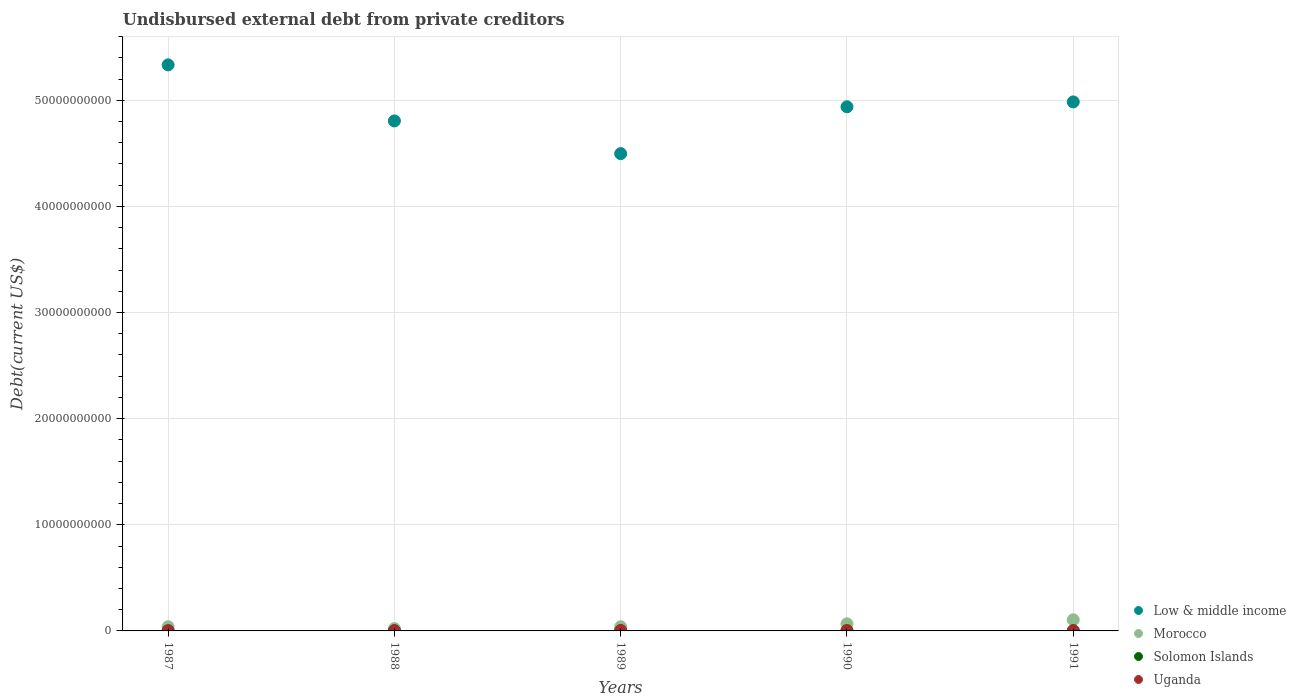Is the number of dotlines equal to the number of legend labels?
Provide a short and direct response. Yes. What is the total debt in Solomon Islands in 1988?
Keep it short and to the point. 1.50e+07. Across all years, what is the maximum total debt in Uganda?
Give a very brief answer. 3.76e+07. Across all years, what is the minimum total debt in Morocco?
Ensure brevity in your answer.  2.19e+08. What is the total total debt in Uganda in the graph?
Keep it short and to the point. 1.10e+08. What is the difference between the total debt in Uganda in 1987 and that in 1988?
Make the answer very short. 3.02e+06. What is the difference between the total debt in Solomon Islands in 1991 and the total debt in Uganda in 1988?
Your answer should be compact. 2.96e+06. What is the average total debt in Solomon Islands per year?
Offer a terse response. 1.50e+07. In the year 1987, what is the difference between the total debt in Solomon Islands and total debt in Low & middle income?
Keep it short and to the point. -5.33e+1. What is the ratio of the total debt in Low & middle income in 1987 to that in 1991?
Your answer should be very brief. 1.07. What is the difference between the highest and the second highest total debt in Uganda?
Your answer should be very brief. 1.44e+07. What is the difference between the highest and the lowest total debt in Low & middle income?
Offer a terse response. 8.36e+09. In how many years, is the total debt in Low & middle income greater than the average total debt in Low & middle income taken over all years?
Provide a succinct answer. 3. Is the sum of the total debt in Uganda in 1987 and 1989 greater than the maximum total debt in Morocco across all years?
Give a very brief answer. No. Is it the case that in every year, the sum of the total debt in Solomon Islands and total debt in Uganda  is greater than the total debt in Morocco?
Your response must be concise. No. Is the total debt in Morocco strictly greater than the total debt in Solomon Islands over the years?
Ensure brevity in your answer.  Yes. Is the total debt in Solomon Islands strictly less than the total debt in Morocco over the years?
Your answer should be compact. Yes. What is the difference between two consecutive major ticks on the Y-axis?
Offer a terse response. 1.00e+1. Does the graph contain grids?
Ensure brevity in your answer.  Yes. Where does the legend appear in the graph?
Your response must be concise. Bottom right. How many legend labels are there?
Provide a succinct answer. 4. How are the legend labels stacked?
Offer a terse response. Vertical. What is the title of the graph?
Offer a terse response. Undisbursed external debt from private creditors. What is the label or title of the Y-axis?
Keep it short and to the point. Debt(current US$). What is the Debt(current US$) in Low & middle income in 1987?
Give a very brief answer. 5.33e+1. What is the Debt(current US$) of Morocco in 1987?
Offer a terse response. 3.91e+08. What is the Debt(current US$) of Solomon Islands in 1987?
Keep it short and to the point. 1.50e+07. What is the Debt(current US$) in Uganda in 1987?
Your answer should be compact. 1.51e+07. What is the Debt(current US$) of Low & middle income in 1988?
Offer a very short reply. 4.81e+1. What is the Debt(current US$) in Morocco in 1988?
Provide a short and direct response. 2.19e+08. What is the Debt(current US$) in Solomon Islands in 1988?
Offer a terse response. 1.50e+07. What is the Debt(current US$) of Uganda in 1988?
Offer a very short reply. 1.20e+07. What is the Debt(current US$) in Low & middle income in 1989?
Offer a very short reply. 4.50e+1. What is the Debt(current US$) of Morocco in 1989?
Provide a short and direct response. 3.90e+08. What is the Debt(current US$) in Solomon Islands in 1989?
Offer a terse response. 1.50e+07. What is the Debt(current US$) in Uganda in 1989?
Give a very brief answer. 3.76e+07. What is the Debt(current US$) in Low & middle income in 1990?
Offer a terse response. 4.94e+1. What is the Debt(current US$) in Morocco in 1990?
Provide a succinct answer. 6.71e+08. What is the Debt(current US$) of Solomon Islands in 1990?
Your answer should be very brief. 1.50e+07. What is the Debt(current US$) in Uganda in 1990?
Give a very brief answer. 2.32e+07. What is the Debt(current US$) in Low & middle income in 1991?
Give a very brief answer. 4.98e+1. What is the Debt(current US$) in Morocco in 1991?
Offer a very short reply. 1.05e+09. What is the Debt(current US$) in Solomon Islands in 1991?
Make the answer very short. 1.50e+07. What is the Debt(current US$) of Uganda in 1991?
Your answer should be very brief. 2.17e+07. Across all years, what is the maximum Debt(current US$) of Low & middle income?
Offer a very short reply. 5.33e+1. Across all years, what is the maximum Debt(current US$) of Morocco?
Provide a succinct answer. 1.05e+09. Across all years, what is the maximum Debt(current US$) of Solomon Islands?
Your answer should be very brief. 1.50e+07. Across all years, what is the maximum Debt(current US$) in Uganda?
Your answer should be very brief. 3.76e+07. Across all years, what is the minimum Debt(current US$) in Low & middle income?
Provide a succinct answer. 4.50e+1. Across all years, what is the minimum Debt(current US$) in Morocco?
Provide a short and direct response. 2.19e+08. Across all years, what is the minimum Debt(current US$) of Solomon Islands?
Keep it short and to the point. 1.50e+07. Across all years, what is the minimum Debt(current US$) of Uganda?
Your response must be concise. 1.20e+07. What is the total Debt(current US$) of Low & middle income in the graph?
Offer a terse response. 2.46e+11. What is the total Debt(current US$) of Morocco in the graph?
Your answer should be very brief. 2.72e+09. What is the total Debt(current US$) in Solomon Islands in the graph?
Ensure brevity in your answer.  7.50e+07. What is the total Debt(current US$) in Uganda in the graph?
Make the answer very short. 1.10e+08. What is the difference between the Debt(current US$) in Low & middle income in 1987 and that in 1988?
Ensure brevity in your answer.  5.28e+09. What is the difference between the Debt(current US$) in Morocco in 1987 and that in 1988?
Give a very brief answer. 1.72e+08. What is the difference between the Debt(current US$) of Solomon Islands in 1987 and that in 1988?
Provide a short and direct response. 0. What is the difference between the Debt(current US$) of Uganda in 1987 and that in 1988?
Provide a short and direct response. 3.02e+06. What is the difference between the Debt(current US$) of Low & middle income in 1987 and that in 1989?
Your response must be concise. 8.36e+09. What is the difference between the Debt(current US$) in Morocco in 1987 and that in 1989?
Give a very brief answer. 1.15e+06. What is the difference between the Debt(current US$) in Uganda in 1987 and that in 1989?
Give a very brief answer. -2.25e+07. What is the difference between the Debt(current US$) in Low & middle income in 1987 and that in 1990?
Provide a succinct answer. 3.95e+09. What is the difference between the Debt(current US$) of Morocco in 1987 and that in 1990?
Your answer should be compact. -2.80e+08. What is the difference between the Debt(current US$) in Solomon Islands in 1987 and that in 1990?
Your response must be concise. 0. What is the difference between the Debt(current US$) in Uganda in 1987 and that in 1990?
Your answer should be very brief. -8.16e+06. What is the difference between the Debt(current US$) in Low & middle income in 1987 and that in 1991?
Keep it short and to the point. 3.49e+09. What is the difference between the Debt(current US$) of Morocco in 1987 and that in 1991?
Your answer should be compact. -6.58e+08. What is the difference between the Debt(current US$) in Uganda in 1987 and that in 1991?
Offer a very short reply. -6.68e+06. What is the difference between the Debt(current US$) of Low & middle income in 1988 and that in 1989?
Ensure brevity in your answer.  3.08e+09. What is the difference between the Debt(current US$) in Morocco in 1988 and that in 1989?
Provide a succinct answer. -1.71e+08. What is the difference between the Debt(current US$) of Solomon Islands in 1988 and that in 1989?
Keep it short and to the point. 0. What is the difference between the Debt(current US$) in Uganda in 1988 and that in 1989?
Provide a succinct answer. -2.55e+07. What is the difference between the Debt(current US$) of Low & middle income in 1988 and that in 1990?
Provide a short and direct response. -1.33e+09. What is the difference between the Debt(current US$) in Morocco in 1988 and that in 1990?
Provide a succinct answer. -4.52e+08. What is the difference between the Debt(current US$) of Uganda in 1988 and that in 1990?
Your response must be concise. -1.12e+07. What is the difference between the Debt(current US$) of Low & middle income in 1988 and that in 1991?
Offer a terse response. -1.79e+09. What is the difference between the Debt(current US$) in Morocco in 1988 and that in 1991?
Provide a short and direct response. -8.29e+08. What is the difference between the Debt(current US$) in Uganda in 1988 and that in 1991?
Keep it short and to the point. -9.70e+06. What is the difference between the Debt(current US$) of Low & middle income in 1989 and that in 1990?
Ensure brevity in your answer.  -4.41e+09. What is the difference between the Debt(current US$) in Morocco in 1989 and that in 1990?
Give a very brief answer. -2.81e+08. What is the difference between the Debt(current US$) of Solomon Islands in 1989 and that in 1990?
Your answer should be compact. 0. What is the difference between the Debt(current US$) of Uganda in 1989 and that in 1990?
Provide a short and direct response. 1.44e+07. What is the difference between the Debt(current US$) in Low & middle income in 1989 and that in 1991?
Offer a very short reply. -4.87e+09. What is the difference between the Debt(current US$) of Morocco in 1989 and that in 1991?
Your response must be concise. -6.59e+08. What is the difference between the Debt(current US$) of Solomon Islands in 1989 and that in 1991?
Give a very brief answer. 0. What is the difference between the Debt(current US$) of Uganda in 1989 and that in 1991?
Offer a very short reply. 1.58e+07. What is the difference between the Debt(current US$) of Low & middle income in 1990 and that in 1991?
Keep it short and to the point. -4.60e+08. What is the difference between the Debt(current US$) of Morocco in 1990 and that in 1991?
Make the answer very short. -3.78e+08. What is the difference between the Debt(current US$) of Uganda in 1990 and that in 1991?
Provide a short and direct response. 1.48e+06. What is the difference between the Debt(current US$) in Low & middle income in 1987 and the Debt(current US$) in Morocco in 1988?
Your answer should be compact. 5.31e+1. What is the difference between the Debt(current US$) of Low & middle income in 1987 and the Debt(current US$) of Solomon Islands in 1988?
Give a very brief answer. 5.33e+1. What is the difference between the Debt(current US$) of Low & middle income in 1987 and the Debt(current US$) of Uganda in 1988?
Provide a succinct answer. 5.33e+1. What is the difference between the Debt(current US$) in Morocco in 1987 and the Debt(current US$) in Solomon Islands in 1988?
Provide a succinct answer. 3.76e+08. What is the difference between the Debt(current US$) in Morocco in 1987 and the Debt(current US$) in Uganda in 1988?
Keep it short and to the point. 3.79e+08. What is the difference between the Debt(current US$) of Solomon Islands in 1987 and the Debt(current US$) of Uganda in 1988?
Provide a succinct answer. 2.96e+06. What is the difference between the Debt(current US$) in Low & middle income in 1987 and the Debt(current US$) in Morocco in 1989?
Offer a terse response. 5.29e+1. What is the difference between the Debt(current US$) of Low & middle income in 1987 and the Debt(current US$) of Solomon Islands in 1989?
Your response must be concise. 5.33e+1. What is the difference between the Debt(current US$) in Low & middle income in 1987 and the Debt(current US$) in Uganda in 1989?
Make the answer very short. 5.33e+1. What is the difference between the Debt(current US$) of Morocco in 1987 and the Debt(current US$) of Solomon Islands in 1989?
Your answer should be very brief. 3.76e+08. What is the difference between the Debt(current US$) in Morocco in 1987 and the Debt(current US$) in Uganda in 1989?
Keep it short and to the point. 3.53e+08. What is the difference between the Debt(current US$) of Solomon Islands in 1987 and the Debt(current US$) of Uganda in 1989?
Your answer should be very brief. -2.26e+07. What is the difference between the Debt(current US$) in Low & middle income in 1987 and the Debt(current US$) in Morocco in 1990?
Keep it short and to the point. 5.27e+1. What is the difference between the Debt(current US$) of Low & middle income in 1987 and the Debt(current US$) of Solomon Islands in 1990?
Make the answer very short. 5.33e+1. What is the difference between the Debt(current US$) in Low & middle income in 1987 and the Debt(current US$) in Uganda in 1990?
Ensure brevity in your answer.  5.33e+1. What is the difference between the Debt(current US$) in Morocco in 1987 and the Debt(current US$) in Solomon Islands in 1990?
Your answer should be compact. 3.76e+08. What is the difference between the Debt(current US$) of Morocco in 1987 and the Debt(current US$) of Uganda in 1990?
Offer a terse response. 3.68e+08. What is the difference between the Debt(current US$) in Solomon Islands in 1987 and the Debt(current US$) in Uganda in 1990?
Offer a terse response. -8.22e+06. What is the difference between the Debt(current US$) of Low & middle income in 1987 and the Debt(current US$) of Morocco in 1991?
Your answer should be compact. 5.23e+1. What is the difference between the Debt(current US$) in Low & middle income in 1987 and the Debt(current US$) in Solomon Islands in 1991?
Offer a terse response. 5.33e+1. What is the difference between the Debt(current US$) in Low & middle income in 1987 and the Debt(current US$) in Uganda in 1991?
Provide a succinct answer. 5.33e+1. What is the difference between the Debt(current US$) of Morocco in 1987 and the Debt(current US$) of Solomon Islands in 1991?
Your answer should be very brief. 3.76e+08. What is the difference between the Debt(current US$) of Morocco in 1987 and the Debt(current US$) of Uganda in 1991?
Your answer should be compact. 3.69e+08. What is the difference between the Debt(current US$) of Solomon Islands in 1987 and the Debt(current US$) of Uganda in 1991?
Give a very brief answer. -6.74e+06. What is the difference between the Debt(current US$) of Low & middle income in 1988 and the Debt(current US$) of Morocco in 1989?
Your response must be concise. 4.77e+1. What is the difference between the Debt(current US$) in Low & middle income in 1988 and the Debt(current US$) in Solomon Islands in 1989?
Your response must be concise. 4.80e+1. What is the difference between the Debt(current US$) of Low & middle income in 1988 and the Debt(current US$) of Uganda in 1989?
Offer a terse response. 4.80e+1. What is the difference between the Debt(current US$) of Morocco in 1988 and the Debt(current US$) of Solomon Islands in 1989?
Give a very brief answer. 2.04e+08. What is the difference between the Debt(current US$) in Morocco in 1988 and the Debt(current US$) in Uganda in 1989?
Make the answer very short. 1.82e+08. What is the difference between the Debt(current US$) in Solomon Islands in 1988 and the Debt(current US$) in Uganda in 1989?
Offer a terse response. -2.26e+07. What is the difference between the Debt(current US$) of Low & middle income in 1988 and the Debt(current US$) of Morocco in 1990?
Ensure brevity in your answer.  4.74e+1. What is the difference between the Debt(current US$) in Low & middle income in 1988 and the Debt(current US$) in Solomon Islands in 1990?
Offer a very short reply. 4.80e+1. What is the difference between the Debt(current US$) in Low & middle income in 1988 and the Debt(current US$) in Uganda in 1990?
Your answer should be compact. 4.80e+1. What is the difference between the Debt(current US$) in Morocco in 1988 and the Debt(current US$) in Solomon Islands in 1990?
Provide a succinct answer. 2.04e+08. What is the difference between the Debt(current US$) of Morocco in 1988 and the Debt(current US$) of Uganda in 1990?
Keep it short and to the point. 1.96e+08. What is the difference between the Debt(current US$) in Solomon Islands in 1988 and the Debt(current US$) in Uganda in 1990?
Your response must be concise. -8.22e+06. What is the difference between the Debt(current US$) of Low & middle income in 1988 and the Debt(current US$) of Morocco in 1991?
Your answer should be very brief. 4.70e+1. What is the difference between the Debt(current US$) of Low & middle income in 1988 and the Debt(current US$) of Solomon Islands in 1991?
Provide a succinct answer. 4.80e+1. What is the difference between the Debt(current US$) of Low & middle income in 1988 and the Debt(current US$) of Uganda in 1991?
Your response must be concise. 4.80e+1. What is the difference between the Debt(current US$) in Morocco in 1988 and the Debt(current US$) in Solomon Islands in 1991?
Offer a very short reply. 2.04e+08. What is the difference between the Debt(current US$) in Morocco in 1988 and the Debt(current US$) in Uganda in 1991?
Provide a short and direct response. 1.97e+08. What is the difference between the Debt(current US$) of Solomon Islands in 1988 and the Debt(current US$) of Uganda in 1991?
Provide a succinct answer. -6.74e+06. What is the difference between the Debt(current US$) in Low & middle income in 1989 and the Debt(current US$) in Morocco in 1990?
Ensure brevity in your answer.  4.43e+1. What is the difference between the Debt(current US$) of Low & middle income in 1989 and the Debt(current US$) of Solomon Islands in 1990?
Make the answer very short. 4.50e+1. What is the difference between the Debt(current US$) of Low & middle income in 1989 and the Debt(current US$) of Uganda in 1990?
Provide a succinct answer. 4.50e+1. What is the difference between the Debt(current US$) of Morocco in 1989 and the Debt(current US$) of Solomon Islands in 1990?
Make the answer very short. 3.75e+08. What is the difference between the Debt(current US$) of Morocco in 1989 and the Debt(current US$) of Uganda in 1990?
Offer a terse response. 3.67e+08. What is the difference between the Debt(current US$) in Solomon Islands in 1989 and the Debt(current US$) in Uganda in 1990?
Your answer should be very brief. -8.22e+06. What is the difference between the Debt(current US$) of Low & middle income in 1989 and the Debt(current US$) of Morocco in 1991?
Provide a short and direct response. 4.39e+1. What is the difference between the Debt(current US$) of Low & middle income in 1989 and the Debt(current US$) of Solomon Islands in 1991?
Offer a terse response. 4.50e+1. What is the difference between the Debt(current US$) in Low & middle income in 1989 and the Debt(current US$) in Uganda in 1991?
Ensure brevity in your answer.  4.50e+1. What is the difference between the Debt(current US$) in Morocco in 1989 and the Debt(current US$) in Solomon Islands in 1991?
Ensure brevity in your answer.  3.75e+08. What is the difference between the Debt(current US$) of Morocco in 1989 and the Debt(current US$) of Uganda in 1991?
Provide a succinct answer. 3.68e+08. What is the difference between the Debt(current US$) of Solomon Islands in 1989 and the Debt(current US$) of Uganda in 1991?
Your answer should be very brief. -6.74e+06. What is the difference between the Debt(current US$) of Low & middle income in 1990 and the Debt(current US$) of Morocco in 1991?
Your response must be concise. 4.83e+1. What is the difference between the Debt(current US$) of Low & middle income in 1990 and the Debt(current US$) of Solomon Islands in 1991?
Your answer should be very brief. 4.94e+1. What is the difference between the Debt(current US$) in Low & middle income in 1990 and the Debt(current US$) in Uganda in 1991?
Ensure brevity in your answer.  4.94e+1. What is the difference between the Debt(current US$) in Morocco in 1990 and the Debt(current US$) in Solomon Islands in 1991?
Offer a very short reply. 6.56e+08. What is the difference between the Debt(current US$) in Morocco in 1990 and the Debt(current US$) in Uganda in 1991?
Keep it short and to the point. 6.49e+08. What is the difference between the Debt(current US$) in Solomon Islands in 1990 and the Debt(current US$) in Uganda in 1991?
Offer a terse response. -6.74e+06. What is the average Debt(current US$) of Low & middle income per year?
Give a very brief answer. 4.91e+1. What is the average Debt(current US$) of Morocco per year?
Give a very brief answer. 5.44e+08. What is the average Debt(current US$) of Solomon Islands per year?
Provide a succinct answer. 1.50e+07. What is the average Debt(current US$) in Uganda per year?
Provide a succinct answer. 2.19e+07. In the year 1987, what is the difference between the Debt(current US$) of Low & middle income and Debt(current US$) of Morocco?
Your answer should be very brief. 5.29e+1. In the year 1987, what is the difference between the Debt(current US$) of Low & middle income and Debt(current US$) of Solomon Islands?
Your response must be concise. 5.33e+1. In the year 1987, what is the difference between the Debt(current US$) of Low & middle income and Debt(current US$) of Uganda?
Ensure brevity in your answer.  5.33e+1. In the year 1987, what is the difference between the Debt(current US$) in Morocco and Debt(current US$) in Solomon Islands?
Make the answer very short. 3.76e+08. In the year 1987, what is the difference between the Debt(current US$) of Morocco and Debt(current US$) of Uganda?
Make the answer very short. 3.76e+08. In the year 1987, what is the difference between the Debt(current US$) in Solomon Islands and Debt(current US$) in Uganda?
Keep it short and to the point. -6.10e+04. In the year 1988, what is the difference between the Debt(current US$) in Low & middle income and Debt(current US$) in Morocco?
Give a very brief answer. 4.78e+1. In the year 1988, what is the difference between the Debt(current US$) of Low & middle income and Debt(current US$) of Solomon Islands?
Ensure brevity in your answer.  4.80e+1. In the year 1988, what is the difference between the Debt(current US$) of Low & middle income and Debt(current US$) of Uganda?
Your response must be concise. 4.80e+1. In the year 1988, what is the difference between the Debt(current US$) in Morocco and Debt(current US$) in Solomon Islands?
Your response must be concise. 2.04e+08. In the year 1988, what is the difference between the Debt(current US$) of Morocco and Debt(current US$) of Uganda?
Your answer should be very brief. 2.07e+08. In the year 1988, what is the difference between the Debt(current US$) in Solomon Islands and Debt(current US$) in Uganda?
Provide a short and direct response. 2.96e+06. In the year 1989, what is the difference between the Debt(current US$) of Low & middle income and Debt(current US$) of Morocco?
Offer a terse response. 4.46e+1. In the year 1989, what is the difference between the Debt(current US$) of Low & middle income and Debt(current US$) of Solomon Islands?
Offer a terse response. 4.50e+1. In the year 1989, what is the difference between the Debt(current US$) in Low & middle income and Debt(current US$) in Uganda?
Offer a very short reply. 4.49e+1. In the year 1989, what is the difference between the Debt(current US$) in Morocco and Debt(current US$) in Solomon Islands?
Offer a terse response. 3.75e+08. In the year 1989, what is the difference between the Debt(current US$) in Morocco and Debt(current US$) in Uganda?
Your answer should be compact. 3.52e+08. In the year 1989, what is the difference between the Debt(current US$) in Solomon Islands and Debt(current US$) in Uganda?
Give a very brief answer. -2.26e+07. In the year 1990, what is the difference between the Debt(current US$) in Low & middle income and Debt(current US$) in Morocco?
Make the answer very short. 4.87e+1. In the year 1990, what is the difference between the Debt(current US$) in Low & middle income and Debt(current US$) in Solomon Islands?
Provide a succinct answer. 4.94e+1. In the year 1990, what is the difference between the Debt(current US$) in Low & middle income and Debt(current US$) in Uganda?
Provide a short and direct response. 4.94e+1. In the year 1990, what is the difference between the Debt(current US$) of Morocco and Debt(current US$) of Solomon Islands?
Your answer should be compact. 6.56e+08. In the year 1990, what is the difference between the Debt(current US$) of Morocco and Debt(current US$) of Uganda?
Your answer should be very brief. 6.47e+08. In the year 1990, what is the difference between the Debt(current US$) of Solomon Islands and Debt(current US$) of Uganda?
Offer a very short reply. -8.22e+06. In the year 1991, what is the difference between the Debt(current US$) of Low & middle income and Debt(current US$) of Morocco?
Give a very brief answer. 4.88e+1. In the year 1991, what is the difference between the Debt(current US$) of Low & middle income and Debt(current US$) of Solomon Islands?
Make the answer very short. 4.98e+1. In the year 1991, what is the difference between the Debt(current US$) of Low & middle income and Debt(current US$) of Uganda?
Keep it short and to the point. 4.98e+1. In the year 1991, what is the difference between the Debt(current US$) of Morocco and Debt(current US$) of Solomon Islands?
Provide a succinct answer. 1.03e+09. In the year 1991, what is the difference between the Debt(current US$) of Morocco and Debt(current US$) of Uganda?
Your response must be concise. 1.03e+09. In the year 1991, what is the difference between the Debt(current US$) in Solomon Islands and Debt(current US$) in Uganda?
Provide a succinct answer. -6.74e+06. What is the ratio of the Debt(current US$) in Low & middle income in 1987 to that in 1988?
Your answer should be compact. 1.11. What is the ratio of the Debt(current US$) of Morocco in 1987 to that in 1988?
Make the answer very short. 1.78. What is the ratio of the Debt(current US$) in Uganda in 1987 to that in 1988?
Provide a short and direct response. 1.25. What is the ratio of the Debt(current US$) in Low & middle income in 1987 to that in 1989?
Keep it short and to the point. 1.19. What is the ratio of the Debt(current US$) in Uganda in 1987 to that in 1989?
Provide a succinct answer. 0.4. What is the ratio of the Debt(current US$) of Low & middle income in 1987 to that in 1990?
Ensure brevity in your answer.  1.08. What is the ratio of the Debt(current US$) in Morocco in 1987 to that in 1990?
Your answer should be compact. 0.58. What is the ratio of the Debt(current US$) in Uganda in 1987 to that in 1990?
Ensure brevity in your answer.  0.65. What is the ratio of the Debt(current US$) of Low & middle income in 1987 to that in 1991?
Offer a terse response. 1.07. What is the ratio of the Debt(current US$) of Morocco in 1987 to that in 1991?
Your response must be concise. 0.37. What is the ratio of the Debt(current US$) of Solomon Islands in 1987 to that in 1991?
Your response must be concise. 1. What is the ratio of the Debt(current US$) in Uganda in 1987 to that in 1991?
Offer a terse response. 0.69. What is the ratio of the Debt(current US$) of Low & middle income in 1988 to that in 1989?
Your response must be concise. 1.07. What is the ratio of the Debt(current US$) of Morocco in 1988 to that in 1989?
Provide a short and direct response. 0.56. What is the ratio of the Debt(current US$) of Uganda in 1988 to that in 1989?
Offer a terse response. 0.32. What is the ratio of the Debt(current US$) of Morocco in 1988 to that in 1990?
Provide a succinct answer. 0.33. What is the ratio of the Debt(current US$) in Solomon Islands in 1988 to that in 1990?
Make the answer very short. 1. What is the ratio of the Debt(current US$) in Uganda in 1988 to that in 1990?
Offer a terse response. 0.52. What is the ratio of the Debt(current US$) in Morocco in 1988 to that in 1991?
Offer a terse response. 0.21. What is the ratio of the Debt(current US$) of Solomon Islands in 1988 to that in 1991?
Your answer should be very brief. 1. What is the ratio of the Debt(current US$) in Uganda in 1988 to that in 1991?
Keep it short and to the point. 0.55. What is the ratio of the Debt(current US$) of Low & middle income in 1989 to that in 1990?
Keep it short and to the point. 0.91. What is the ratio of the Debt(current US$) in Morocco in 1989 to that in 1990?
Provide a succinct answer. 0.58. What is the ratio of the Debt(current US$) in Solomon Islands in 1989 to that in 1990?
Ensure brevity in your answer.  1. What is the ratio of the Debt(current US$) in Uganda in 1989 to that in 1990?
Give a very brief answer. 1.62. What is the ratio of the Debt(current US$) of Low & middle income in 1989 to that in 1991?
Keep it short and to the point. 0.9. What is the ratio of the Debt(current US$) in Morocco in 1989 to that in 1991?
Offer a very short reply. 0.37. What is the ratio of the Debt(current US$) in Uganda in 1989 to that in 1991?
Make the answer very short. 1.73. What is the ratio of the Debt(current US$) in Low & middle income in 1990 to that in 1991?
Provide a succinct answer. 0.99. What is the ratio of the Debt(current US$) of Morocco in 1990 to that in 1991?
Ensure brevity in your answer.  0.64. What is the ratio of the Debt(current US$) in Uganda in 1990 to that in 1991?
Give a very brief answer. 1.07. What is the difference between the highest and the second highest Debt(current US$) of Low & middle income?
Your response must be concise. 3.49e+09. What is the difference between the highest and the second highest Debt(current US$) in Morocco?
Ensure brevity in your answer.  3.78e+08. What is the difference between the highest and the second highest Debt(current US$) of Uganda?
Provide a short and direct response. 1.44e+07. What is the difference between the highest and the lowest Debt(current US$) in Low & middle income?
Provide a succinct answer. 8.36e+09. What is the difference between the highest and the lowest Debt(current US$) of Morocco?
Ensure brevity in your answer.  8.29e+08. What is the difference between the highest and the lowest Debt(current US$) in Solomon Islands?
Provide a succinct answer. 0. What is the difference between the highest and the lowest Debt(current US$) in Uganda?
Offer a terse response. 2.55e+07. 